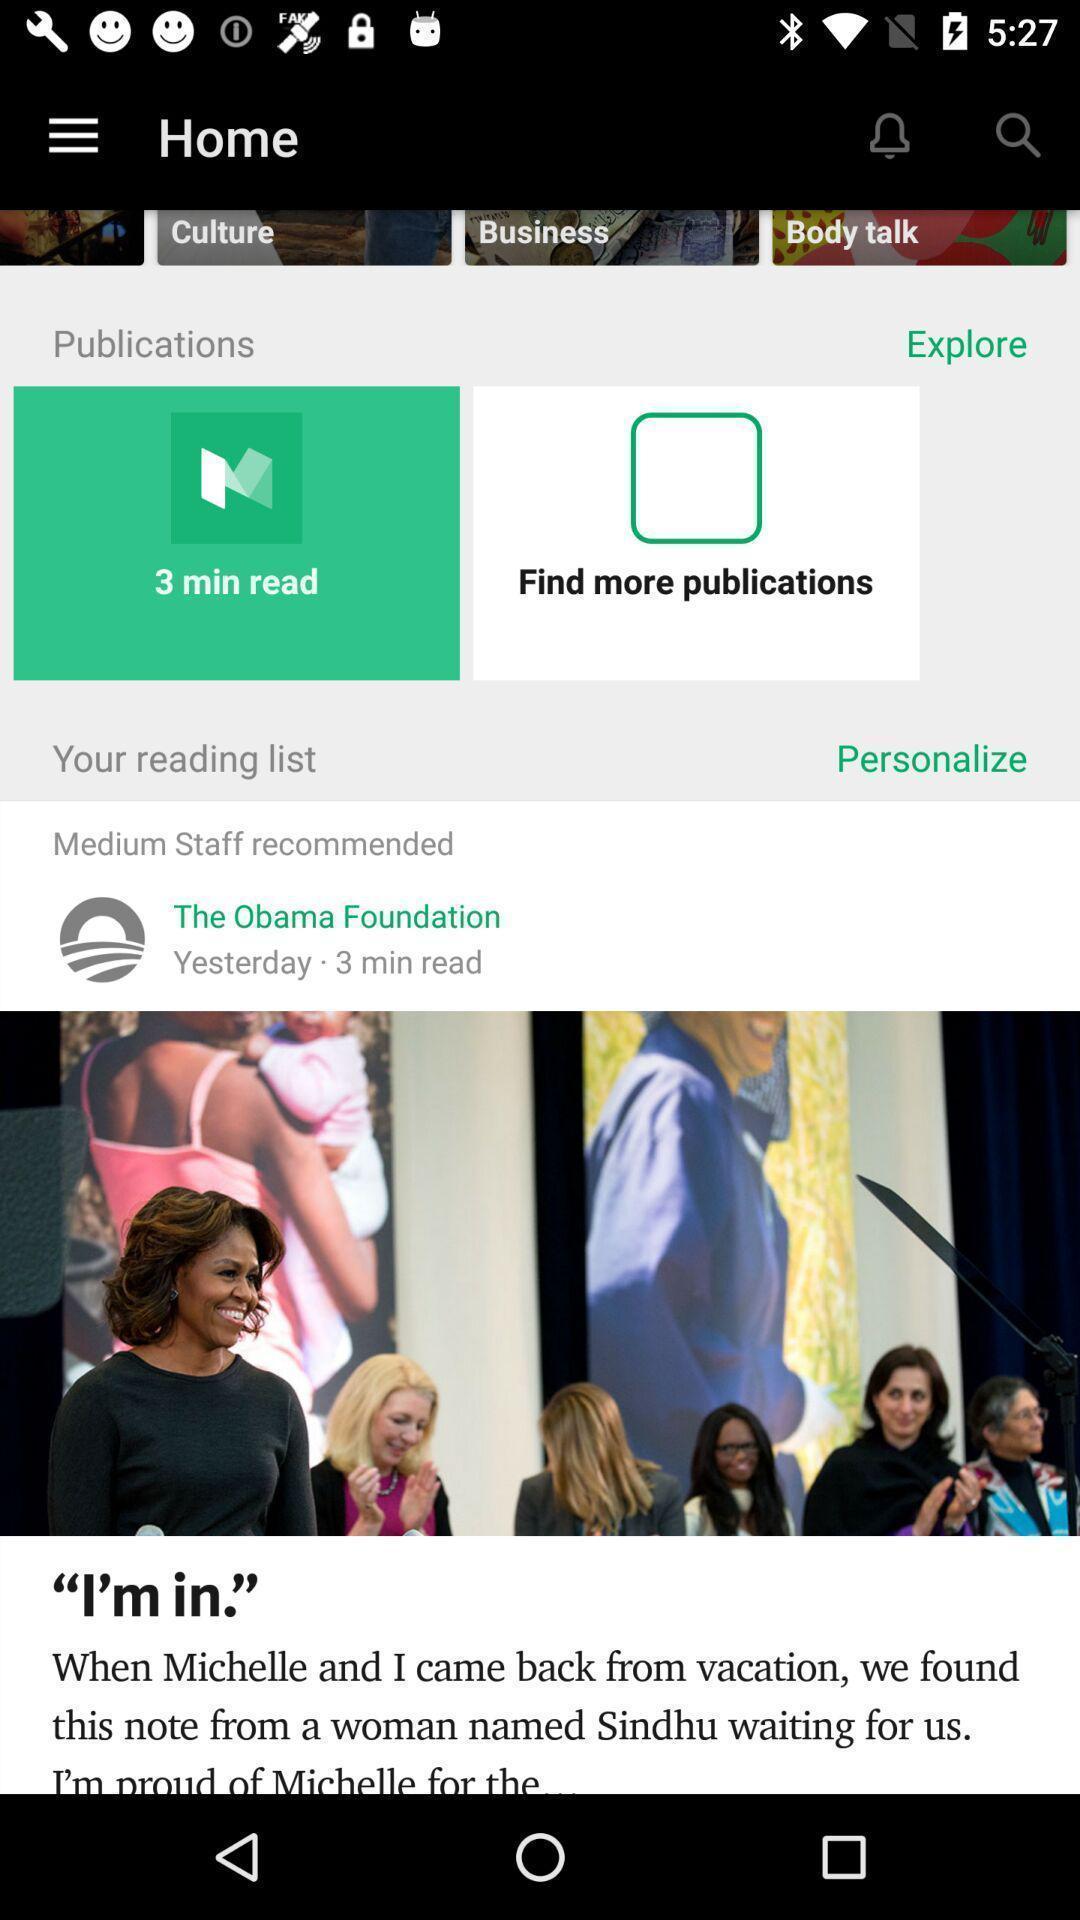What is the overall content of this screenshot? Screen shows home page of a news application. 